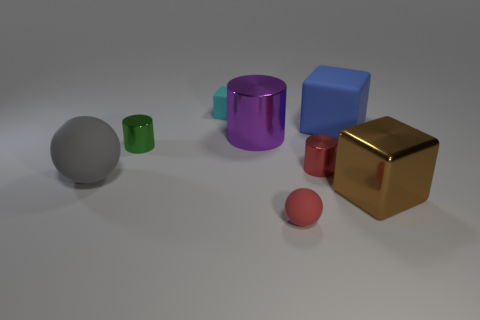Subtract all green shiny cylinders. How many cylinders are left? 2 Subtract 1 blocks. How many blocks are left? 2 Add 2 gray things. How many objects exist? 10 Subtract all gray blocks. Subtract all green cylinders. How many blocks are left? 3 Subtract all balls. How many objects are left? 6 Subtract 1 blue cubes. How many objects are left? 7 Subtract all brown matte cubes. Subtract all gray matte objects. How many objects are left? 7 Add 1 big blue blocks. How many big blue blocks are left? 2 Add 3 small red rubber spheres. How many small red rubber spheres exist? 4 